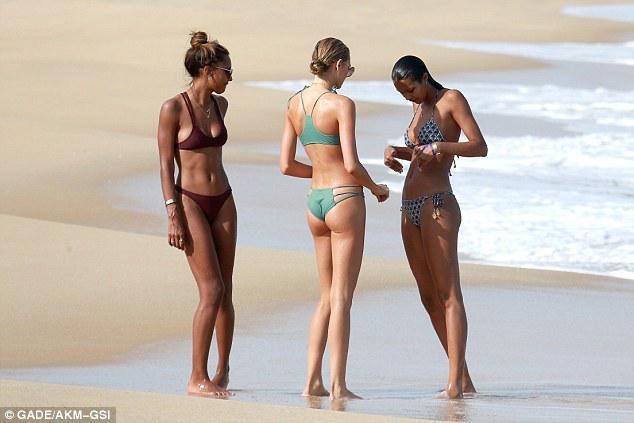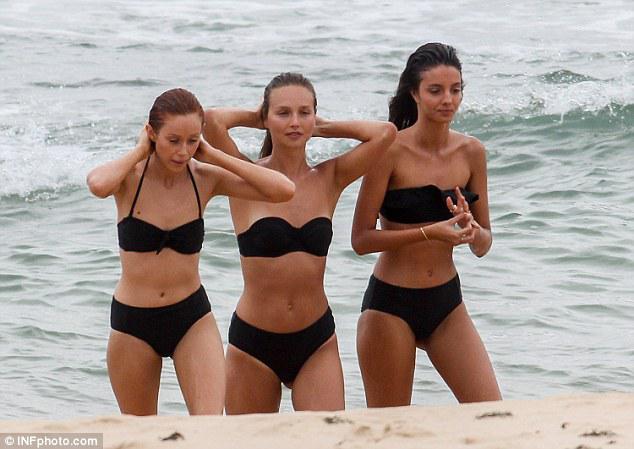The first image is the image on the left, the second image is the image on the right. Examine the images to the left and right. Is the description "One of the women is wearing a bright pink two piece bikini." accurate? Answer yes or no. No. The first image is the image on the left, the second image is the image on the right. Considering the images on both sides, is "Three girls stand side-by-side in bikini tops, and all wear the same color bottoms." valid? Answer yes or no. Yes. 